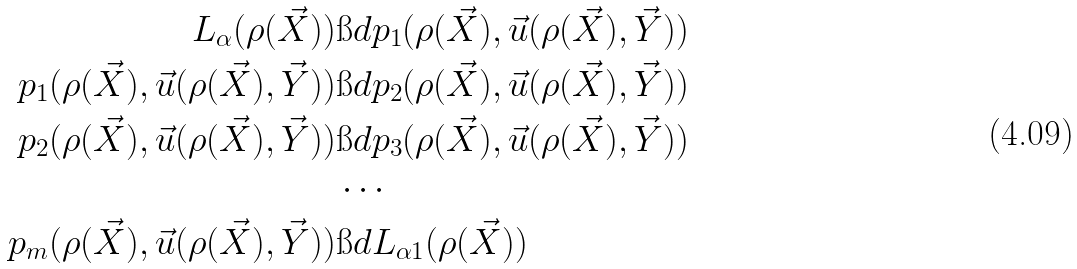<formula> <loc_0><loc_0><loc_500><loc_500>L _ { \alpha } ( \rho ( \vec { X } ) ) & \i d p _ { 1 } ( \rho ( \vec { X } ) , \vec { u } ( \rho ( \vec { X } ) , \vec { Y } ) ) \\ p _ { 1 } ( \rho ( \vec { X } ) , \vec { u } ( \rho ( \vec { X } ) , \vec { Y } ) ) & \i d p _ { 2 } ( \rho ( \vec { X } ) , \vec { u } ( \rho ( \vec { X } ) , \vec { Y } ) ) \\ p _ { 2 } ( \rho ( \vec { X } ) , \vec { u } ( \rho ( \vec { X } ) , \vec { Y } ) ) & \i d p _ { 3 } ( \rho ( \vec { X } ) , \vec { u } ( \rho ( \vec { X } ) , \vec { Y } ) ) \\ & \cdots \\ p _ { m } ( \rho ( \vec { X } ) , \vec { u } ( \rho ( \vec { X } ) , \vec { Y } ) ) & \i d L _ { \alpha 1 } ( \rho ( \vec { X } ) )</formula> 